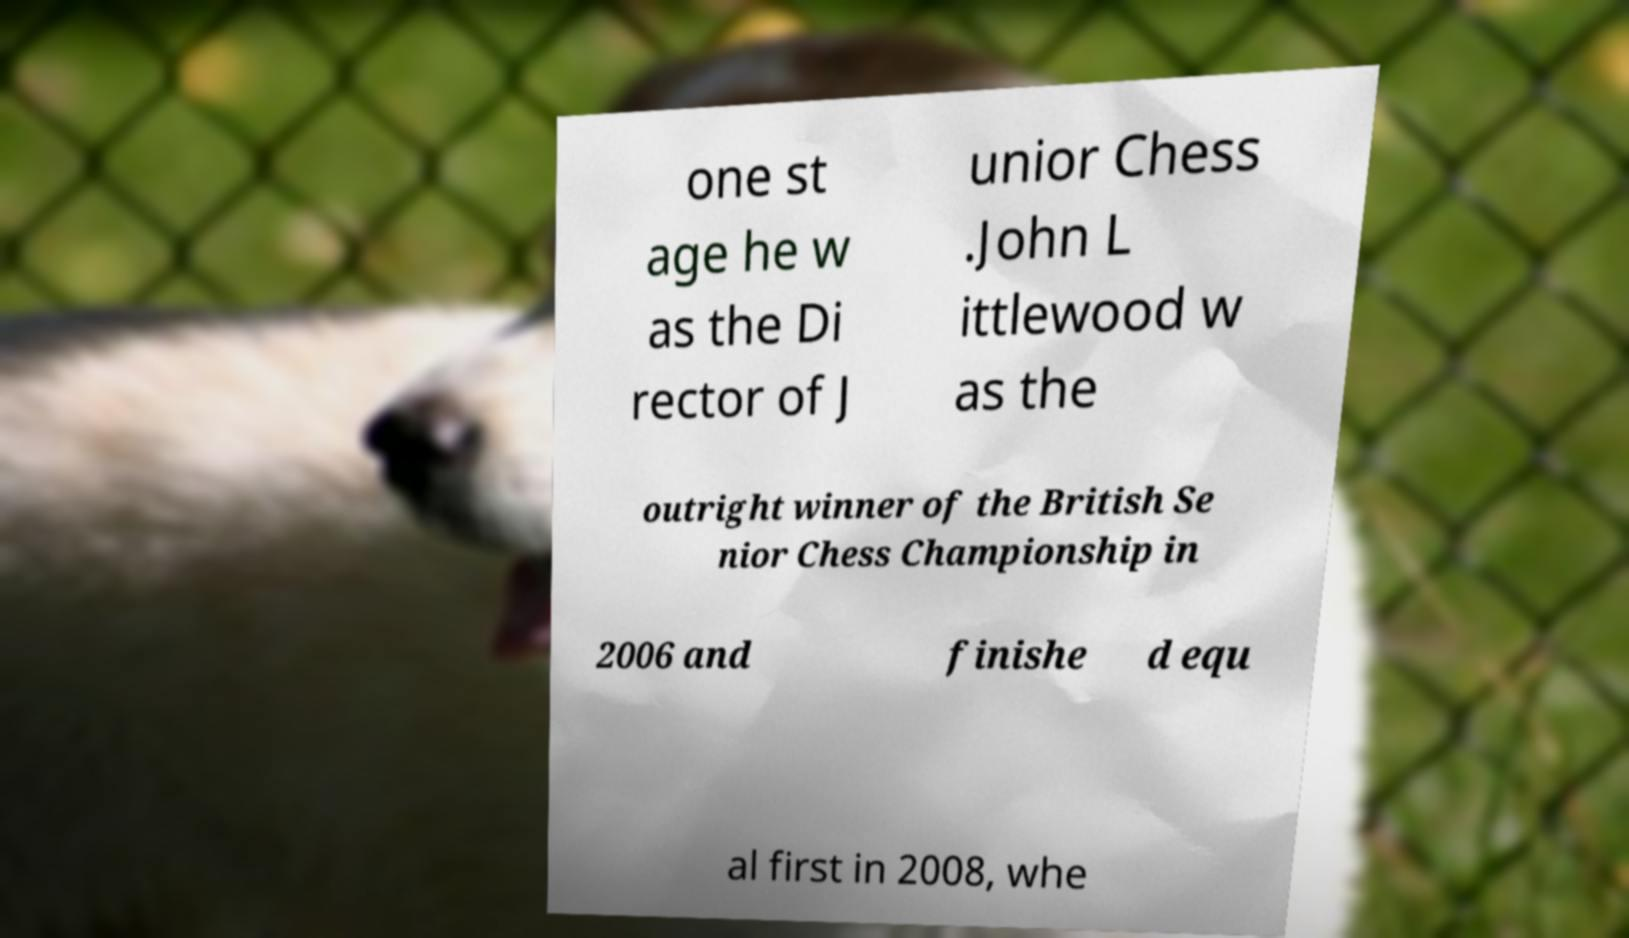Please identify and transcribe the text found in this image. one st age he w as the Di rector of J unior Chess .John L ittlewood w as the outright winner of the British Se nior Chess Championship in 2006 and finishe d equ al first in 2008, whe 